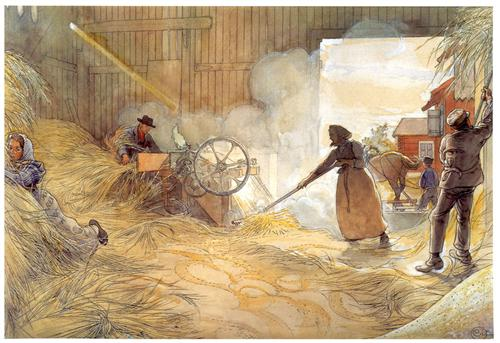What's happening in the scene? The image is a detailed watercolor painting that vividly portrays a group of individuals engaged in the manual labor of threshing grain inside a barn. The scene is brought to life through realistic artistry, capturing the essence of daily rural life. Various tools, characteristic of traditional grain threshing, are scattered around as individuals focus intently on their tasks. The barn’s interior is bathed in warm, earthy tones which juxtapose beautifully with the brighter colors of the workers' clothing, adding a touch of vibrancy to the rustic setting. This painting excels in the genre of genre painting, which celebrates the ordinary aspects of daily life while offering a window into the historical agricultural practices and community spirit of the time. It’s a frozen moment that allows viewers to immerse themselves in the hard-working yet harmonious atmosphere of the barn. 